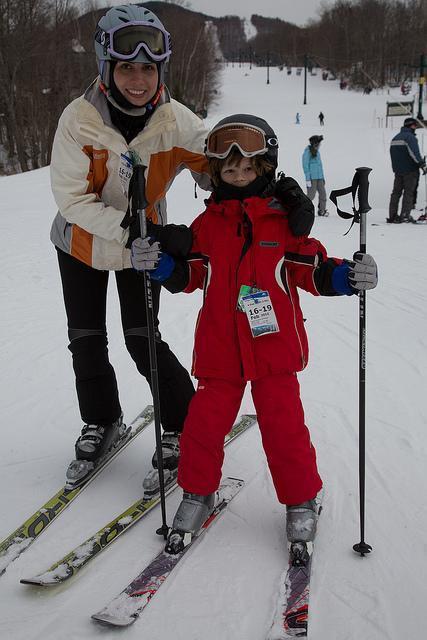What kind of tag hangs from the child in red's jacket?
Choose the correct response, then elucidate: 'Answer: answer
Rationale: rationale.'
Options: Ski pass, birth certificate, hall pass, bank statement. Answer: birth certificate.
Rationale: A square ticket is hanging from a person's coat who has skis on and is on a ski run. 